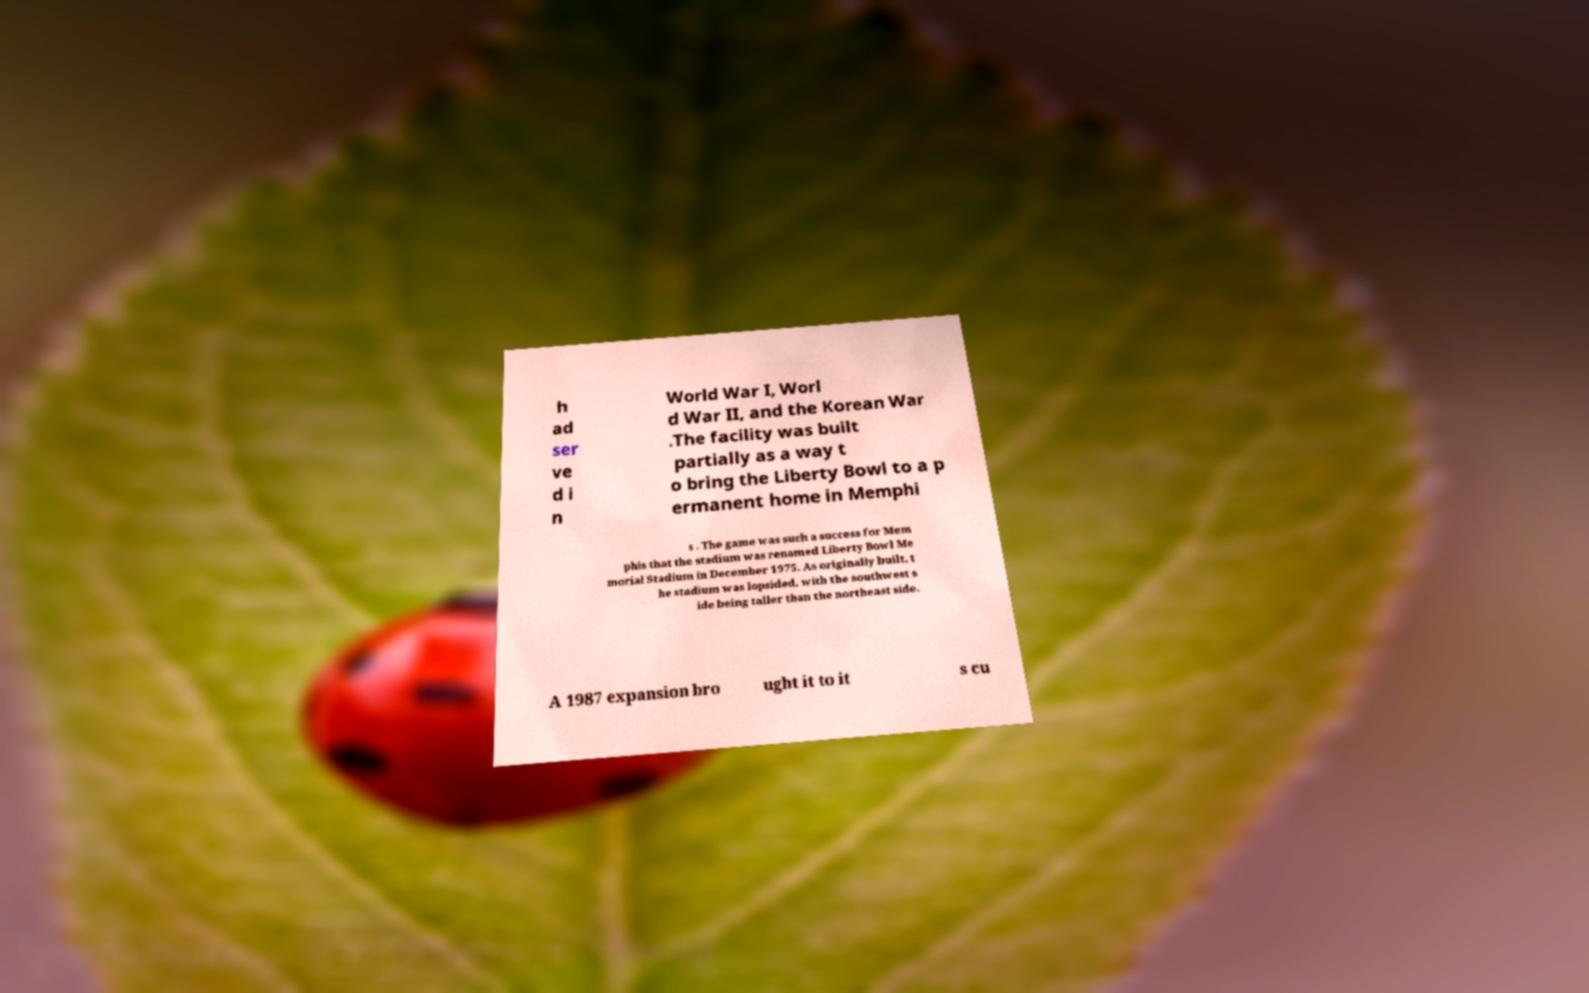For documentation purposes, I need the text within this image transcribed. Could you provide that? h ad ser ve d i n World War I, Worl d War II, and the Korean War .The facility was built partially as a way t o bring the Liberty Bowl to a p ermanent home in Memphi s . The game was such a success for Mem phis that the stadium was renamed Liberty Bowl Me morial Stadium in December 1975. As originally built, t he stadium was lopsided, with the southwest s ide being taller than the northeast side. A 1987 expansion bro ught it to it s cu 